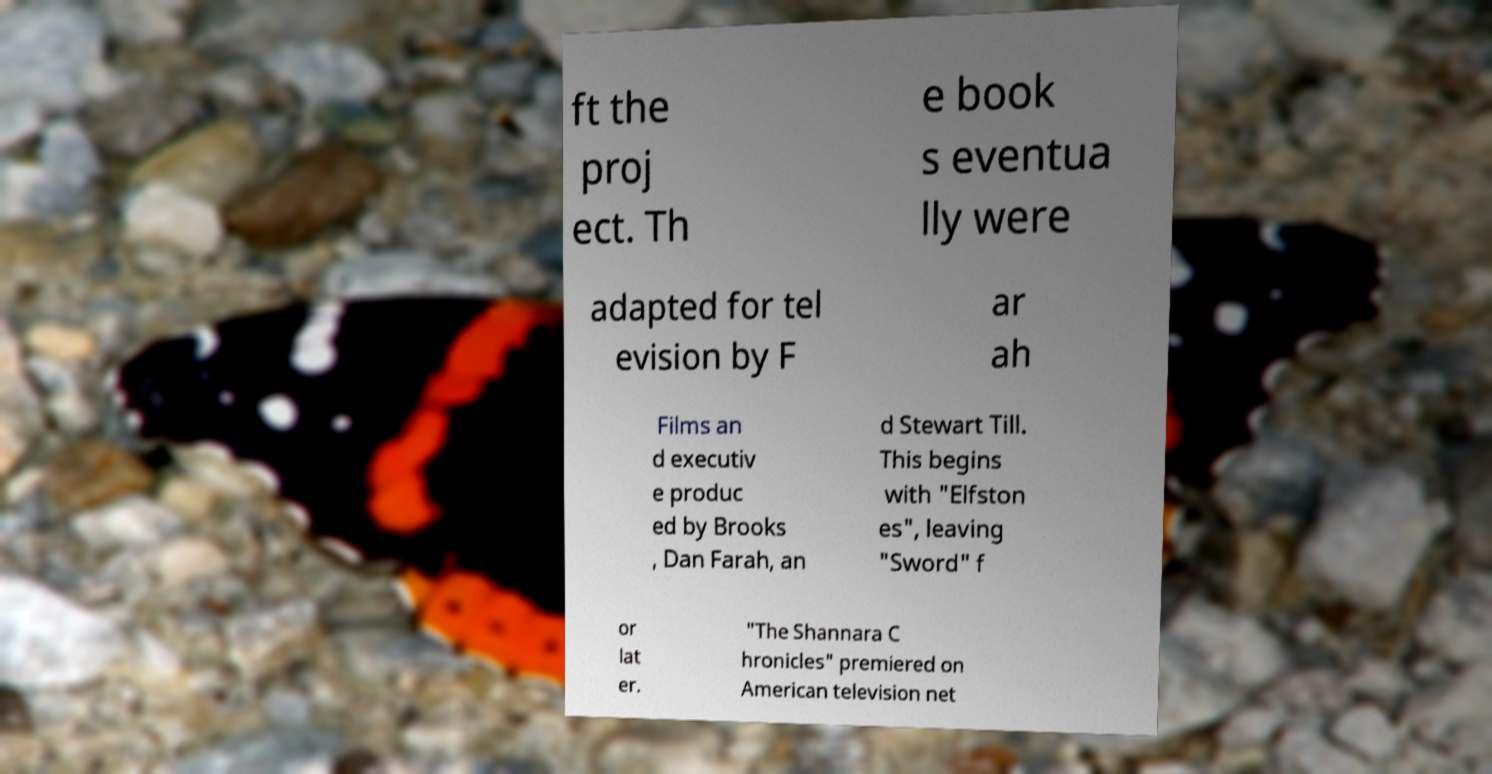Can you read and provide the text displayed in the image?This photo seems to have some interesting text. Can you extract and type it out for me? ft the proj ect. Th e book s eventua lly were adapted for tel evision by F ar ah Films an d executiv e produc ed by Brooks , Dan Farah, an d Stewart Till. This begins with "Elfston es", leaving "Sword" f or lat er. "The Shannara C hronicles" premiered on American television net 